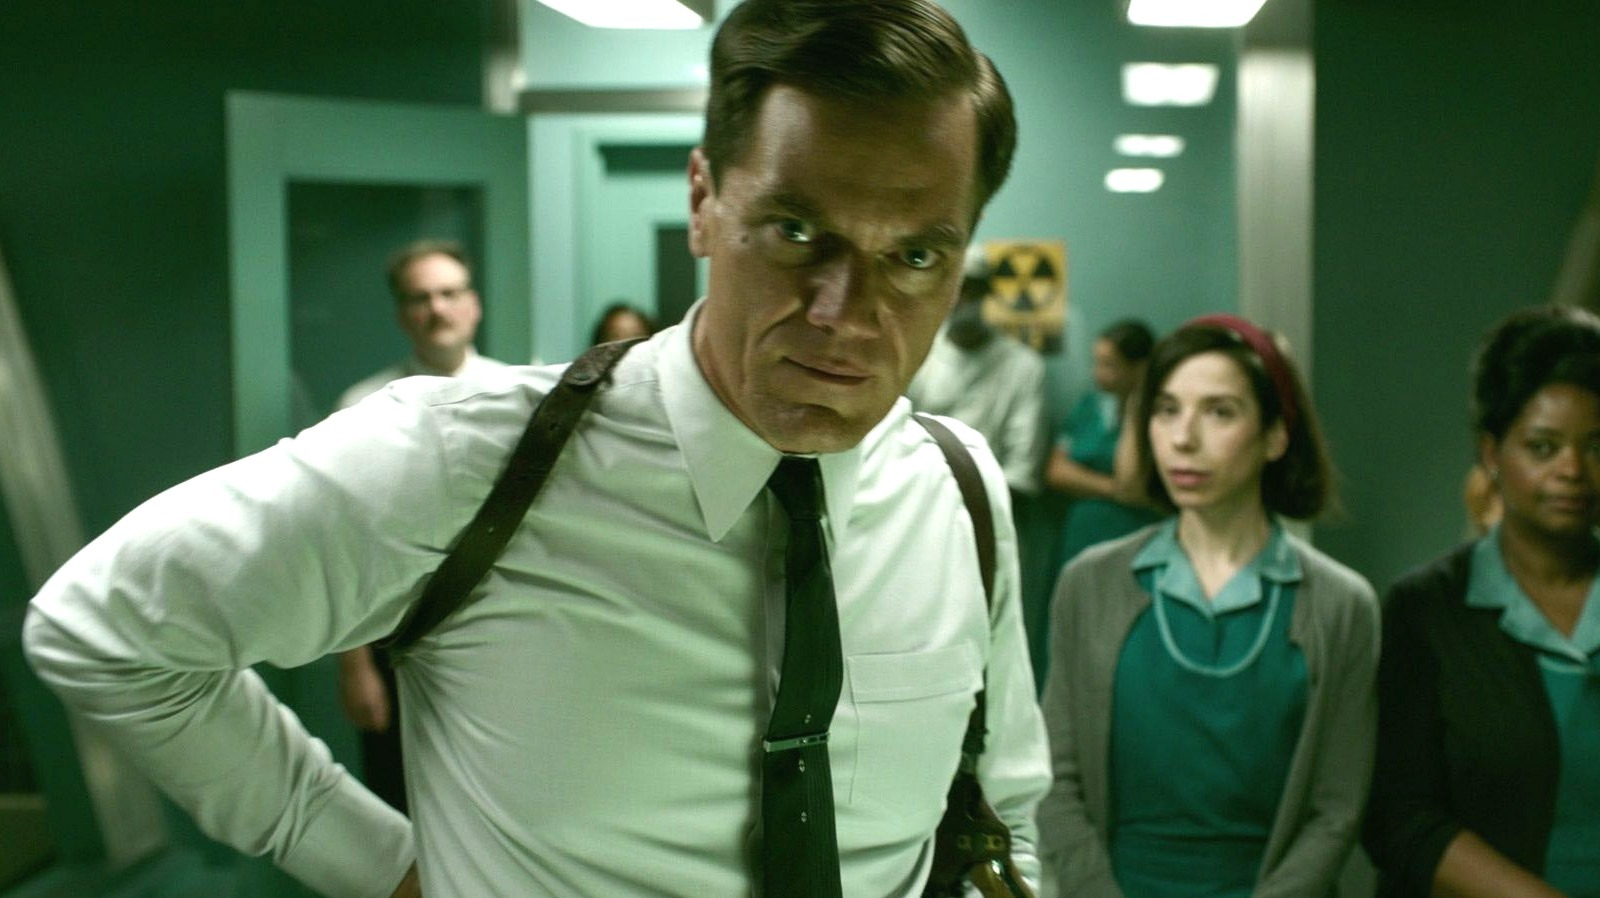What is the interaction between the characters in the background suggesting about the overall atmosphere in the room? The characters in the background, with their various expressions ranging from concern to curiosity, add a layer of complexity to the scene. There seems to be a palpable tension or anticipation among them, suggesting that the room is charged with a mix of emotions likely due to the critical nature of the events taking place. 